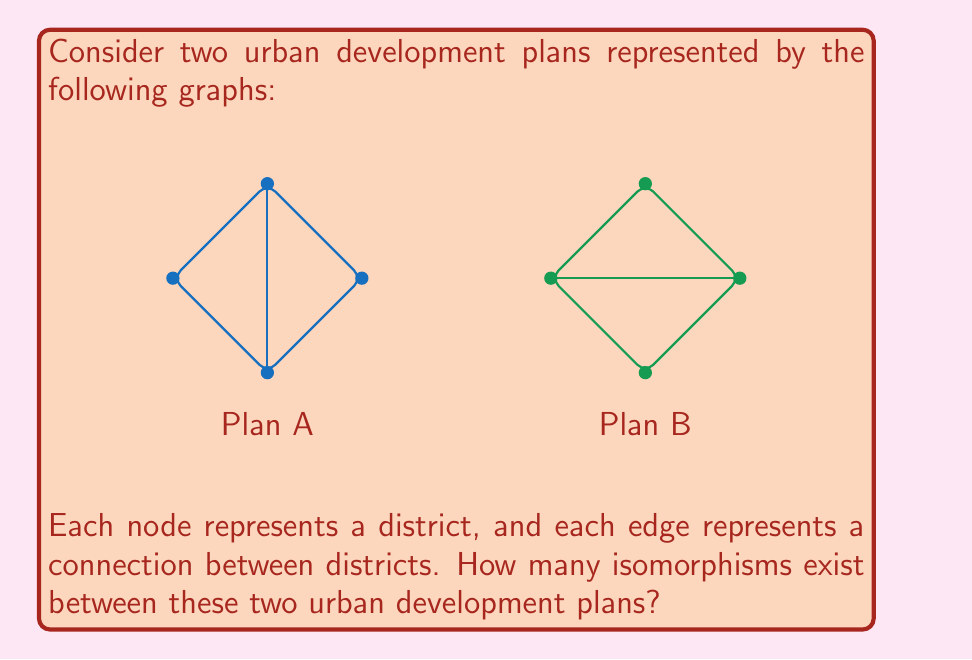Teach me how to tackle this problem. To determine the number of isomorphisms between the two urban development plans, we need to follow these steps:

1) First, we need to confirm that the graphs are indeed isomorphic. They both have:
   - 4 vertices (districts)
   - 5 edges (connections)
   - The same degree sequence: (3, 3, 2, 2)

2) The graphs are isomorphic, so we proceed to count the number of isomorphisms.

3) In Plan A, we have two vertices of degree 3 (top and bottom) and two vertices of degree 2 (left and right).

4) In Plan B, we also have two vertices of degree 3 (left and right) and two vertices of degree 2 (top and bottom).

5) For an isomorphism, vertices of degree 3 must map to vertices of degree 3, and vertices of degree 2 must map to vertices of degree 2.

6) We have two choices for mapping the degree 3 vertices:
   - Top of A to left of B, bottom of A to right of B
   - Top of A to right of B, bottom of A to left of B

7) Once we've mapped the degree 3 vertices, we have two choices for mapping the degree 2 vertices:
   - Left of A to top of B, right of A to bottom of B
   - Left of A to bottom of B, right of A to top of B

8) By the multiplication principle, the total number of isomorphisms is:
   $$ 2 \times 2 = 4 $$

Therefore, there are 4 distinct isomorphisms between the two urban development plans.
Answer: 4 